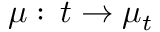Convert formula to latex. <formula><loc_0><loc_0><loc_500><loc_500>\mu \colon \, t \to \mu _ { t }</formula> 